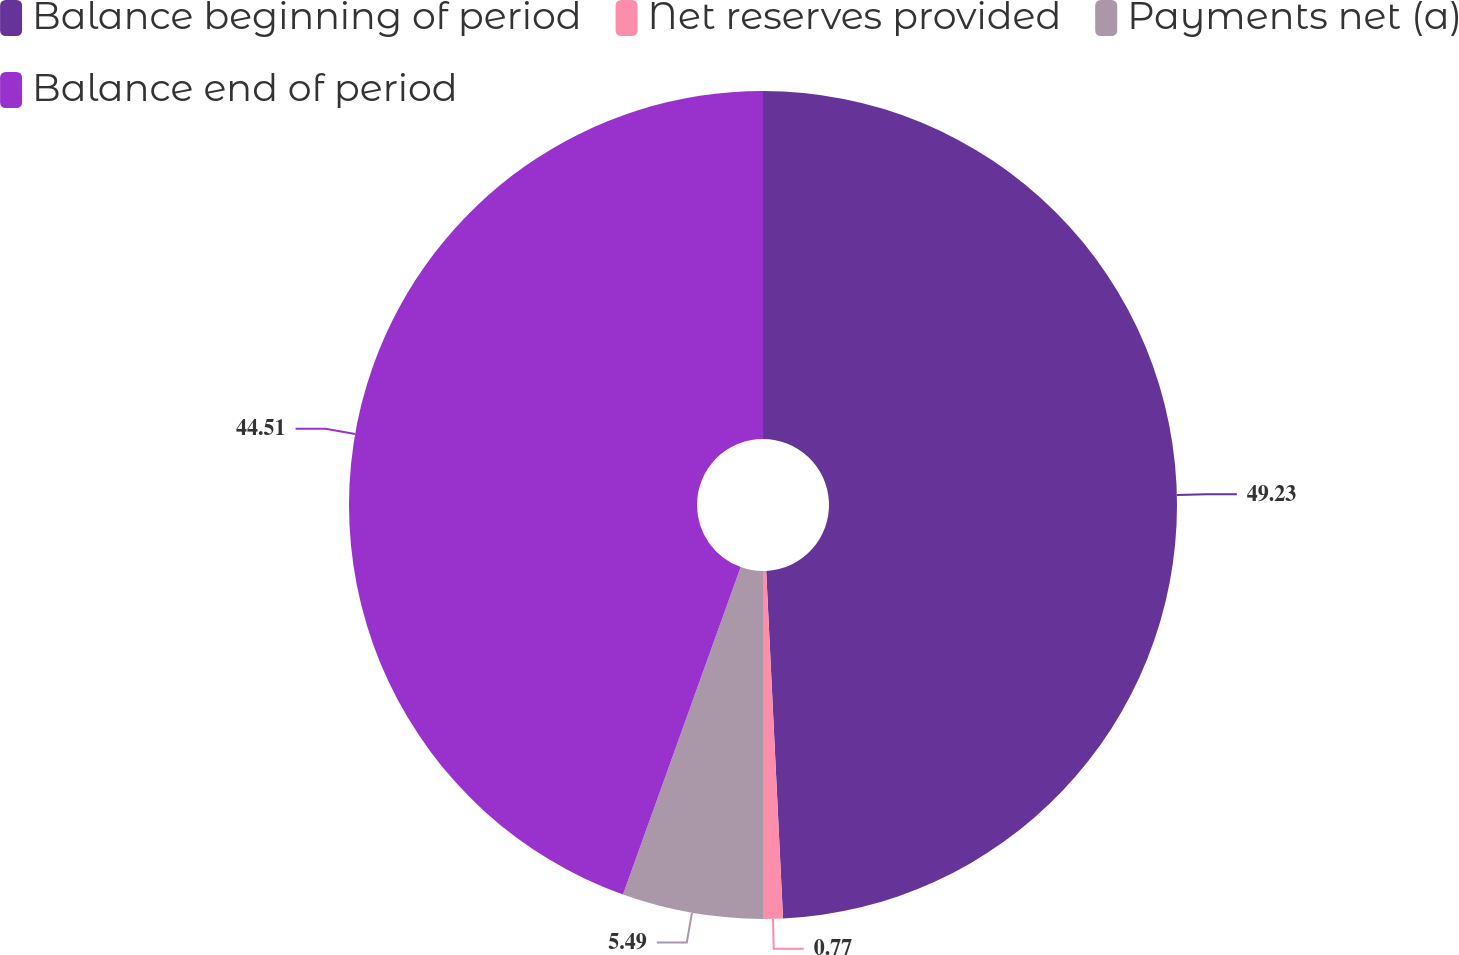Convert chart to OTSL. <chart><loc_0><loc_0><loc_500><loc_500><pie_chart><fcel>Balance beginning of period<fcel>Net reserves provided<fcel>Payments net (a)<fcel>Balance end of period<nl><fcel>49.23%<fcel>0.77%<fcel>5.49%<fcel>44.51%<nl></chart> 